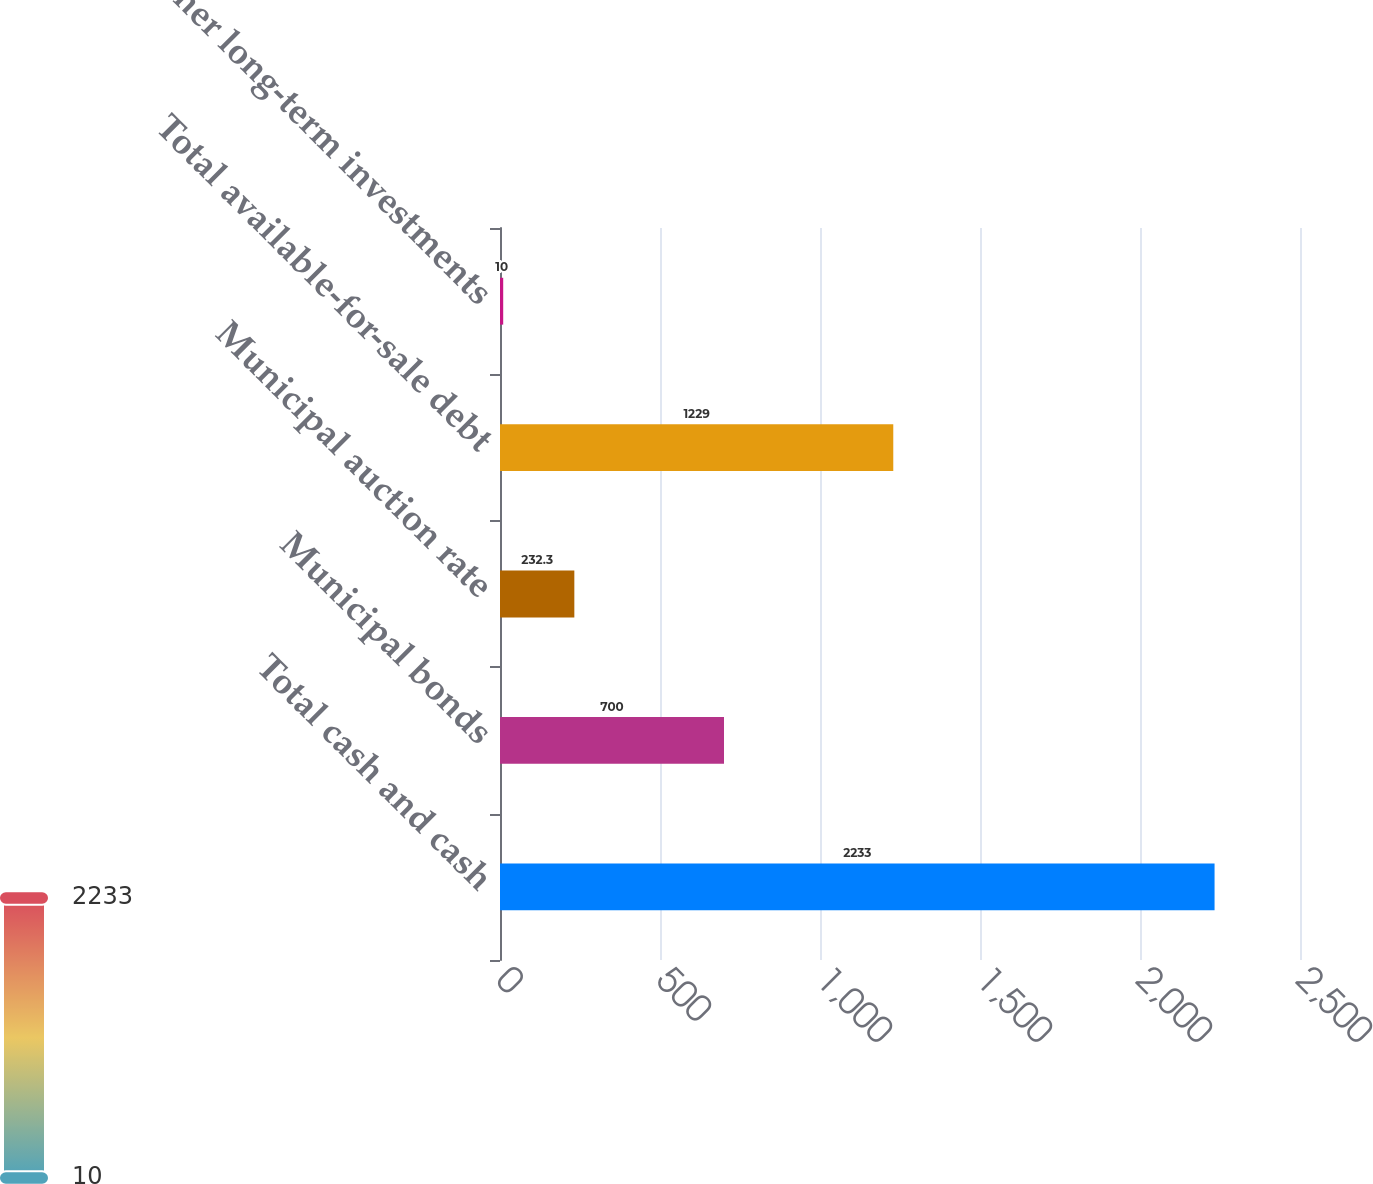Convert chart. <chart><loc_0><loc_0><loc_500><loc_500><bar_chart><fcel>Total cash and cash<fcel>Municipal bonds<fcel>Municipal auction rate<fcel>Total available-for-sale debt<fcel>Other long-term investments<nl><fcel>2233<fcel>700<fcel>232.3<fcel>1229<fcel>10<nl></chart> 